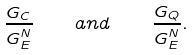Convert formula to latex. <formula><loc_0><loc_0><loc_500><loc_500>\frac { G _ { C } } { G _ { E } ^ { N } } \quad a n d \quad \frac { G _ { Q } } { G _ { E } ^ { N } } .</formula> 